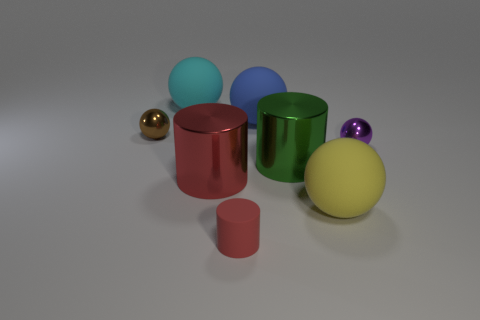Does the spatial arrangement of the objects suggest any particular pattern or structure? The objects are arranged in a manner that might suggest no intentional pattern at first glance. They are dispersed with varying distances between them. However, upon closer inspection, one could interpret a loose grid-like structure, with objects placed at different depths to create a sense of three-dimensionality. The arrangement seems to prioritize a balanced composition rather than a rigid geometric pattern. 